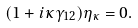<formula> <loc_0><loc_0><loc_500><loc_500>( 1 + i \kappa \gamma _ { 1 2 } ) \eta _ { \kappa } = 0 .</formula> 